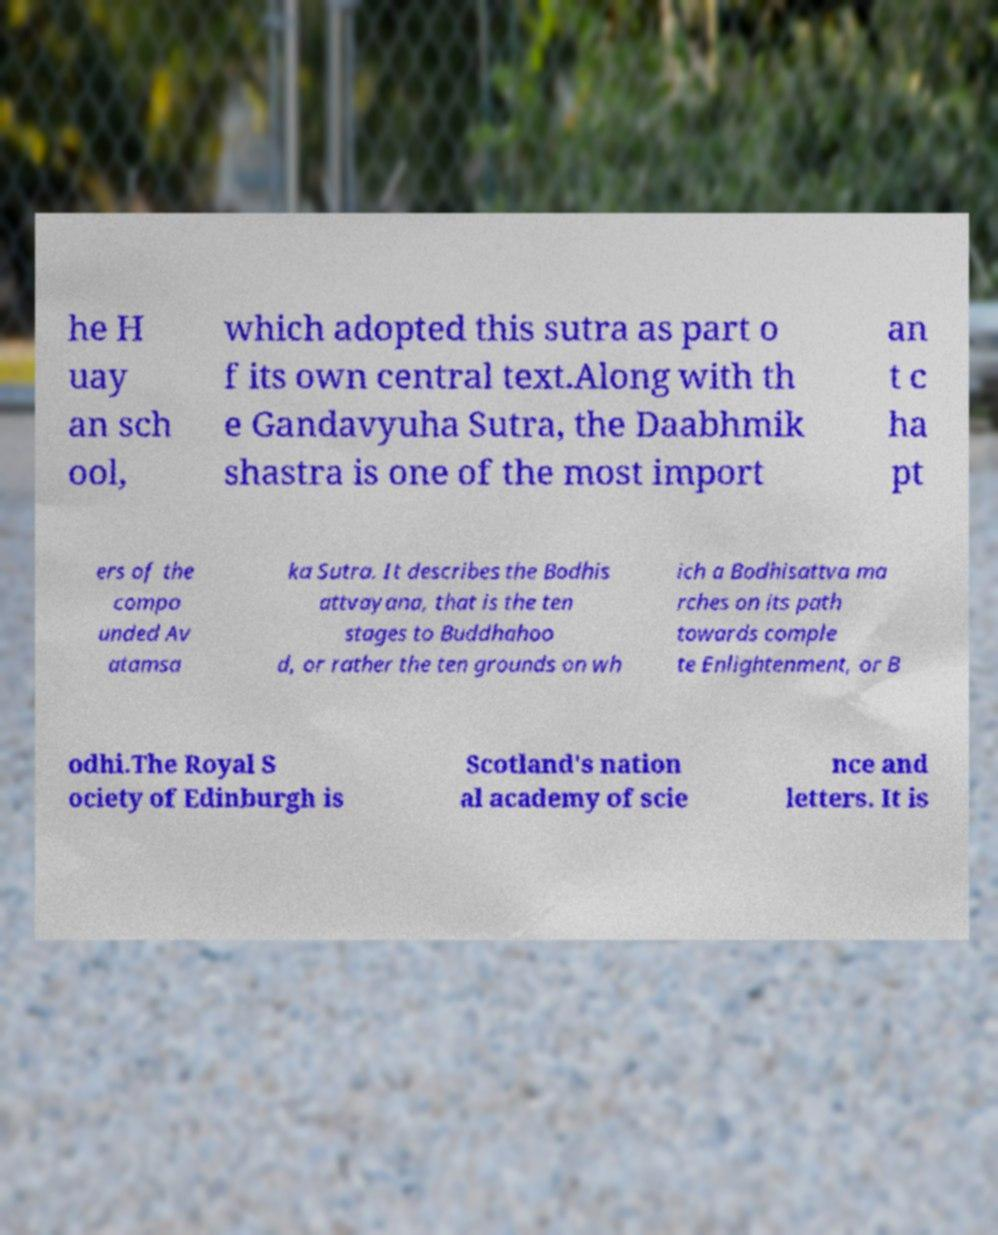For documentation purposes, I need the text within this image transcribed. Could you provide that? he H uay an sch ool, which adopted this sutra as part o f its own central text.Along with th e Gandavyuha Sutra, the Daabhmik shastra is one of the most import an t c ha pt ers of the compo unded Av atamsa ka Sutra. It describes the Bodhis attvayana, that is the ten stages to Buddhahoo d, or rather the ten grounds on wh ich a Bodhisattva ma rches on its path towards comple te Enlightenment, or B odhi.The Royal S ociety of Edinburgh is Scotland's nation al academy of scie nce and letters. It is 